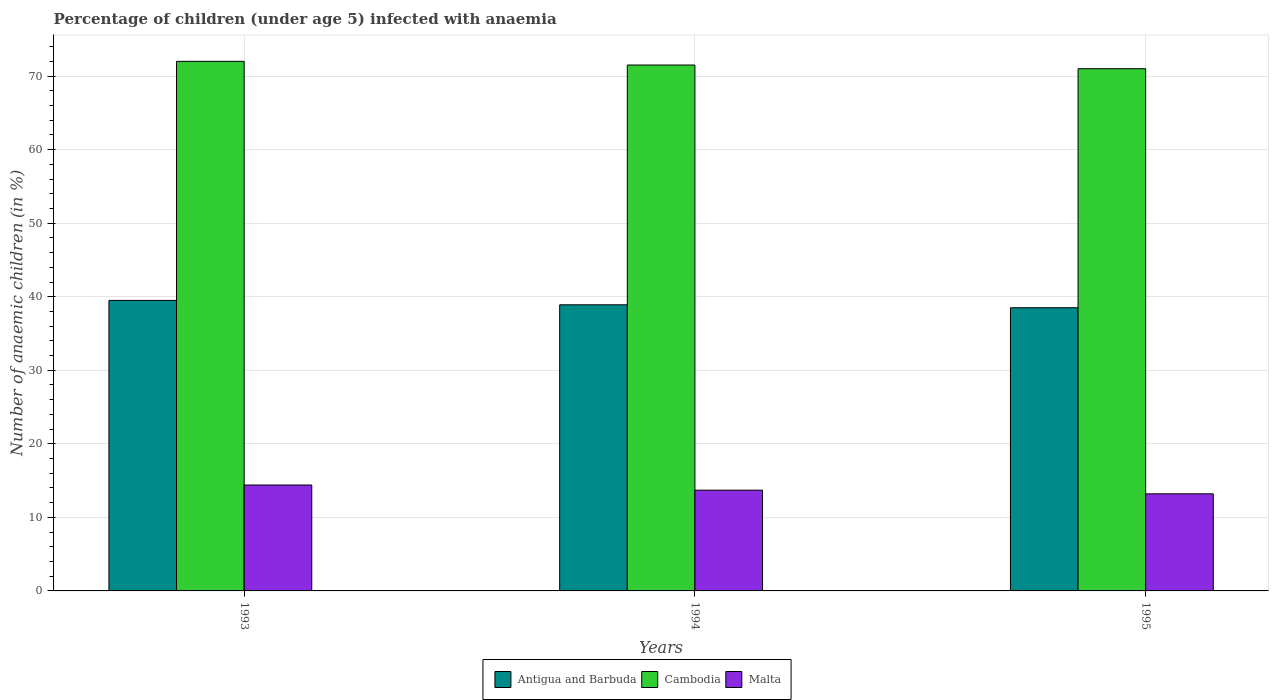How many different coloured bars are there?
Offer a very short reply. 3. Are the number of bars on each tick of the X-axis equal?
Give a very brief answer. Yes. Across all years, what is the minimum percentage of children infected with anaemia in in Antigua and Barbuda?
Make the answer very short. 38.5. In which year was the percentage of children infected with anaemia in in Malta maximum?
Provide a succinct answer. 1993. In which year was the percentage of children infected with anaemia in in Cambodia minimum?
Provide a short and direct response. 1995. What is the total percentage of children infected with anaemia in in Cambodia in the graph?
Offer a terse response. 214.5. What is the difference between the percentage of children infected with anaemia in in Antigua and Barbuda in 1993 and the percentage of children infected with anaemia in in Malta in 1994?
Make the answer very short. 25.8. What is the average percentage of children infected with anaemia in in Malta per year?
Provide a short and direct response. 13.77. In the year 1993, what is the difference between the percentage of children infected with anaemia in in Cambodia and percentage of children infected with anaemia in in Antigua and Barbuda?
Provide a succinct answer. 32.5. In how many years, is the percentage of children infected with anaemia in in Cambodia greater than 62 %?
Ensure brevity in your answer.  3. What is the ratio of the percentage of children infected with anaemia in in Malta in 1994 to that in 1995?
Your answer should be compact. 1.04. What is the difference between the highest and the second highest percentage of children infected with anaemia in in Malta?
Make the answer very short. 0.7. What is the difference between the highest and the lowest percentage of children infected with anaemia in in Cambodia?
Ensure brevity in your answer.  1. What does the 1st bar from the left in 1994 represents?
Ensure brevity in your answer.  Antigua and Barbuda. What does the 2nd bar from the right in 1995 represents?
Provide a succinct answer. Cambodia. Are all the bars in the graph horizontal?
Ensure brevity in your answer.  No. How many years are there in the graph?
Give a very brief answer. 3. Are the values on the major ticks of Y-axis written in scientific E-notation?
Offer a very short reply. No. Does the graph contain grids?
Provide a short and direct response. Yes. Where does the legend appear in the graph?
Provide a succinct answer. Bottom center. How many legend labels are there?
Your response must be concise. 3. How are the legend labels stacked?
Make the answer very short. Horizontal. What is the title of the graph?
Provide a short and direct response. Percentage of children (under age 5) infected with anaemia. What is the label or title of the Y-axis?
Your response must be concise. Number of anaemic children (in %). What is the Number of anaemic children (in %) of Antigua and Barbuda in 1993?
Make the answer very short. 39.5. What is the Number of anaemic children (in %) in Cambodia in 1993?
Provide a short and direct response. 72. What is the Number of anaemic children (in %) in Malta in 1993?
Keep it short and to the point. 14.4. What is the Number of anaemic children (in %) of Antigua and Barbuda in 1994?
Ensure brevity in your answer.  38.9. What is the Number of anaemic children (in %) of Cambodia in 1994?
Ensure brevity in your answer.  71.5. What is the Number of anaemic children (in %) in Antigua and Barbuda in 1995?
Your answer should be compact. 38.5. Across all years, what is the maximum Number of anaemic children (in %) in Antigua and Barbuda?
Provide a short and direct response. 39.5. Across all years, what is the maximum Number of anaemic children (in %) of Cambodia?
Make the answer very short. 72. Across all years, what is the maximum Number of anaemic children (in %) of Malta?
Ensure brevity in your answer.  14.4. Across all years, what is the minimum Number of anaemic children (in %) of Antigua and Barbuda?
Ensure brevity in your answer.  38.5. Across all years, what is the minimum Number of anaemic children (in %) in Cambodia?
Your answer should be compact. 71. Across all years, what is the minimum Number of anaemic children (in %) in Malta?
Provide a succinct answer. 13.2. What is the total Number of anaemic children (in %) in Antigua and Barbuda in the graph?
Your answer should be compact. 116.9. What is the total Number of anaemic children (in %) in Cambodia in the graph?
Give a very brief answer. 214.5. What is the total Number of anaemic children (in %) in Malta in the graph?
Provide a succinct answer. 41.3. What is the difference between the Number of anaemic children (in %) of Antigua and Barbuda in 1993 and that in 1994?
Give a very brief answer. 0.6. What is the difference between the Number of anaemic children (in %) of Antigua and Barbuda in 1993 and that in 1995?
Your answer should be very brief. 1. What is the difference between the Number of anaemic children (in %) in Cambodia in 1993 and that in 1995?
Your answer should be very brief. 1. What is the difference between the Number of anaemic children (in %) of Antigua and Barbuda in 1994 and that in 1995?
Your answer should be compact. 0.4. What is the difference between the Number of anaemic children (in %) in Cambodia in 1994 and that in 1995?
Give a very brief answer. 0.5. What is the difference between the Number of anaemic children (in %) in Antigua and Barbuda in 1993 and the Number of anaemic children (in %) in Cambodia in 1994?
Make the answer very short. -32. What is the difference between the Number of anaemic children (in %) of Antigua and Barbuda in 1993 and the Number of anaemic children (in %) of Malta in 1994?
Offer a terse response. 25.8. What is the difference between the Number of anaemic children (in %) of Cambodia in 1993 and the Number of anaemic children (in %) of Malta in 1994?
Make the answer very short. 58.3. What is the difference between the Number of anaemic children (in %) in Antigua and Barbuda in 1993 and the Number of anaemic children (in %) in Cambodia in 1995?
Provide a succinct answer. -31.5. What is the difference between the Number of anaemic children (in %) of Antigua and Barbuda in 1993 and the Number of anaemic children (in %) of Malta in 1995?
Your response must be concise. 26.3. What is the difference between the Number of anaemic children (in %) in Cambodia in 1993 and the Number of anaemic children (in %) in Malta in 1995?
Your answer should be very brief. 58.8. What is the difference between the Number of anaemic children (in %) of Antigua and Barbuda in 1994 and the Number of anaemic children (in %) of Cambodia in 1995?
Your response must be concise. -32.1. What is the difference between the Number of anaemic children (in %) in Antigua and Barbuda in 1994 and the Number of anaemic children (in %) in Malta in 1995?
Ensure brevity in your answer.  25.7. What is the difference between the Number of anaemic children (in %) of Cambodia in 1994 and the Number of anaemic children (in %) of Malta in 1995?
Offer a very short reply. 58.3. What is the average Number of anaemic children (in %) in Antigua and Barbuda per year?
Your answer should be compact. 38.97. What is the average Number of anaemic children (in %) in Cambodia per year?
Ensure brevity in your answer.  71.5. What is the average Number of anaemic children (in %) of Malta per year?
Your response must be concise. 13.77. In the year 1993, what is the difference between the Number of anaemic children (in %) of Antigua and Barbuda and Number of anaemic children (in %) of Cambodia?
Provide a succinct answer. -32.5. In the year 1993, what is the difference between the Number of anaemic children (in %) in Antigua and Barbuda and Number of anaemic children (in %) in Malta?
Offer a terse response. 25.1. In the year 1993, what is the difference between the Number of anaemic children (in %) in Cambodia and Number of anaemic children (in %) in Malta?
Give a very brief answer. 57.6. In the year 1994, what is the difference between the Number of anaemic children (in %) in Antigua and Barbuda and Number of anaemic children (in %) in Cambodia?
Offer a terse response. -32.6. In the year 1994, what is the difference between the Number of anaemic children (in %) of Antigua and Barbuda and Number of anaemic children (in %) of Malta?
Ensure brevity in your answer.  25.2. In the year 1994, what is the difference between the Number of anaemic children (in %) in Cambodia and Number of anaemic children (in %) in Malta?
Keep it short and to the point. 57.8. In the year 1995, what is the difference between the Number of anaemic children (in %) of Antigua and Barbuda and Number of anaemic children (in %) of Cambodia?
Keep it short and to the point. -32.5. In the year 1995, what is the difference between the Number of anaemic children (in %) in Antigua and Barbuda and Number of anaemic children (in %) in Malta?
Your answer should be very brief. 25.3. In the year 1995, what is the difference between the Number of anaemic children (in %) in Cambodia and Number of anaemic children (in %) in Malta?
Give a very brief answer. 57.8. What is the ratio of the Number of anaemic children (in %) of Antigua and Barbuda in 1993 to that in 1994?
Your response must be concise. 1.02. What is the ratio of the Number of anaemic children (in %) in Cambodia in 1993 to that in 1994?
Ensure brevity in your answer.  1.01. What is the ratio of the Number of anaemic children (in %) of Malta in 1993 to that in 1994?
Provide a short and direct response. 1.05. What is the ratio of the Number of anaemic children (in %) in Cambodia in 1993 to that in 1995?
Your answer should be compact. 1.01. What is the ratio of the Number of anaemic children (in %) in Malta in 1993 to that in 1995?
Make the answer very short. 1.09. What is the ratio of the Number of anaemic children (in %) in Antigua and Barbuda in 1994 to that in 1995?
Your answer should be very brief. 1.01. What is the ratio of the Number of anaemic children (in %) in Cambodia in 1994 to that in 1995?
Your response must be concise. 1.01. What is the ratio of the Number of anaemic children (in %) of Malta in 1994 to that in 1995?
Give a very brief answer. 1.04. What is the difference between the highest and the second highest Number of anaemic children (in %) of Antigua and Barbuda?
Your answer should be very brief. 0.6. What is the difference between the highest and the second highest Number of anaemic children (in %) in Cambodia?
Give a very brief answer. 0.5. What is the difference between the highest and the lowest Number of anaemic children (in %) of Malta?
Your response must be concise. 1.2. 